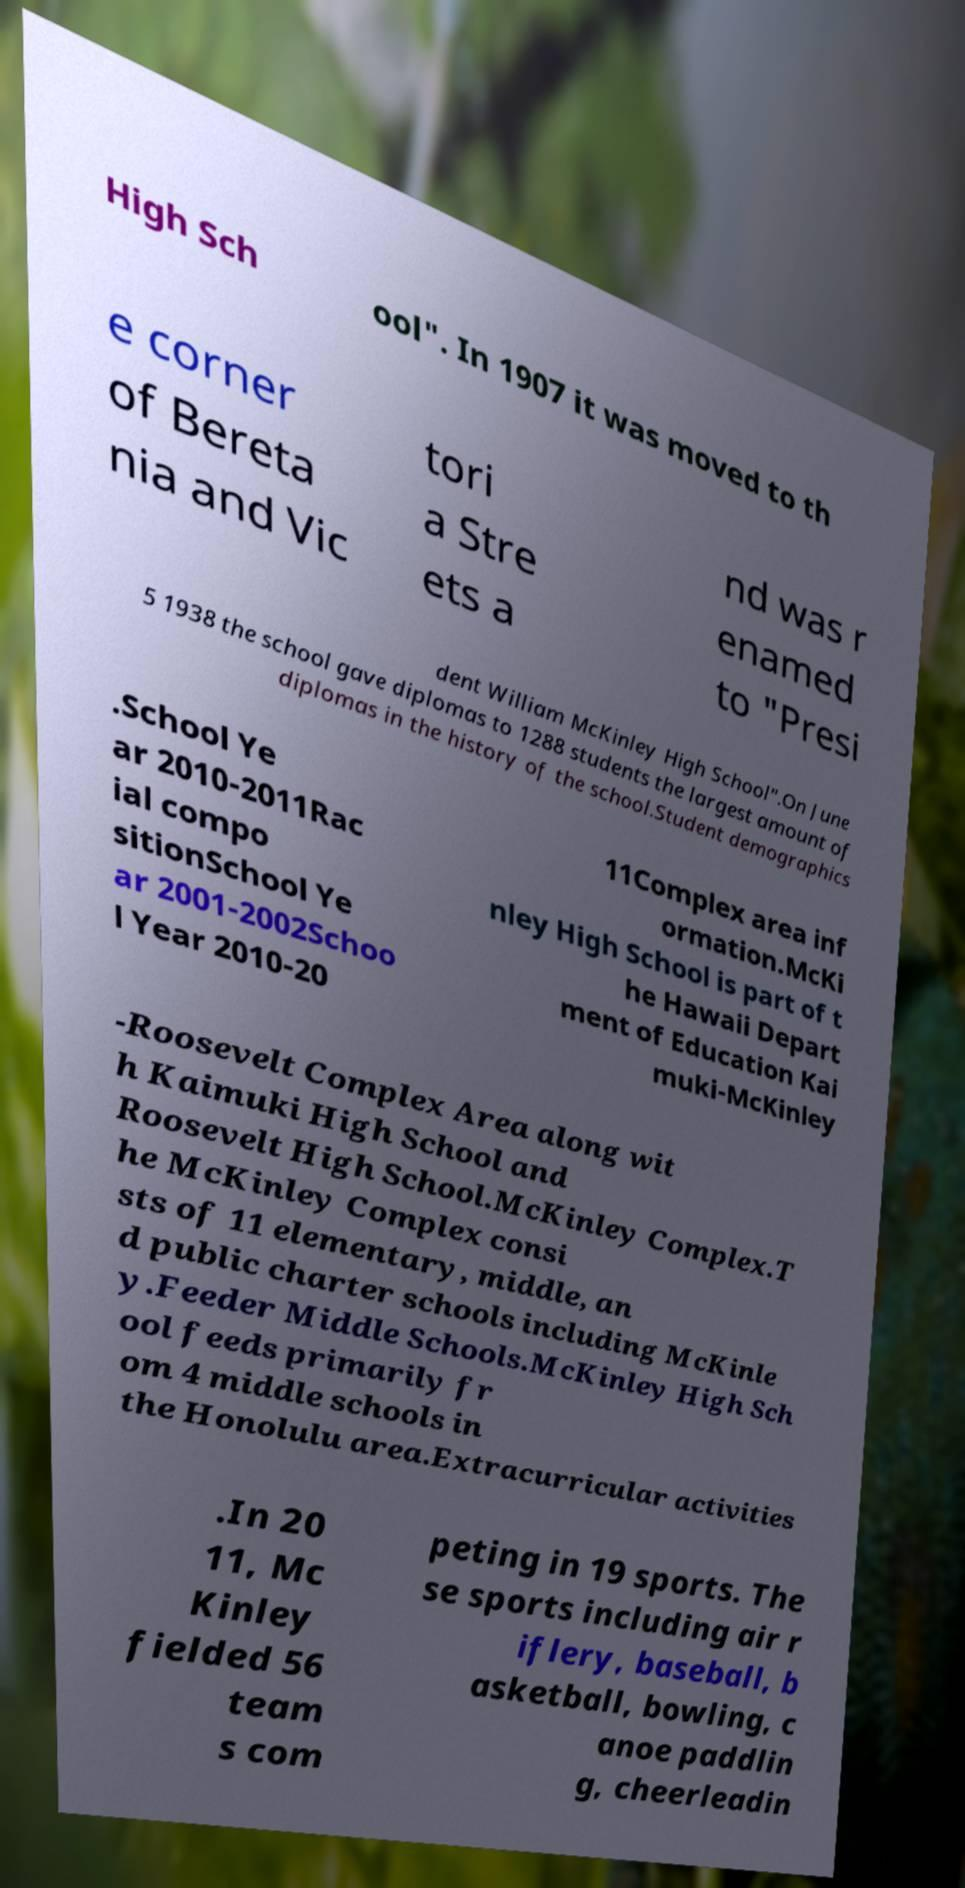Please read and relay the text visible in this image. What does it say? High Sch ool". In 1907 it was moved to th e corner of Bereta nia and Vic tori a Stre ets a nd was r enamed to "Presi dent William McKinley High School".On June 5 1938 the school gave diplomas to 1288 students the largest amount of diplomas in the history of the school.Student demographics .School Ye ar 2010-2011Rac ial compo sitionSchool Ye ar 2001-2002Schoo l Year 2010-20 11Complex area inf ormation.McKi nley High School is part of t he Hawaii Depart ment of Education Kai muki-McKinley -Roosevelt Complex Area along wit h Kaimuki High School and Roosevelt High School.McKinley Complex.T he McKinley Complex consi sts of 11 elementary, middle, an d public charter schools including McKinle y.Feeder Middle Schools.McKinley High Sch ool feeds primarily fr om 4 middle schools in the Honolulu area.Extracurricular activities .In 20 11, Mc Kinley fielded 56 team s com peting in 19 sports. The se sports including air r iflery, baseball, b asketball, bowling, c anoe paddlin g, cheerleadin 